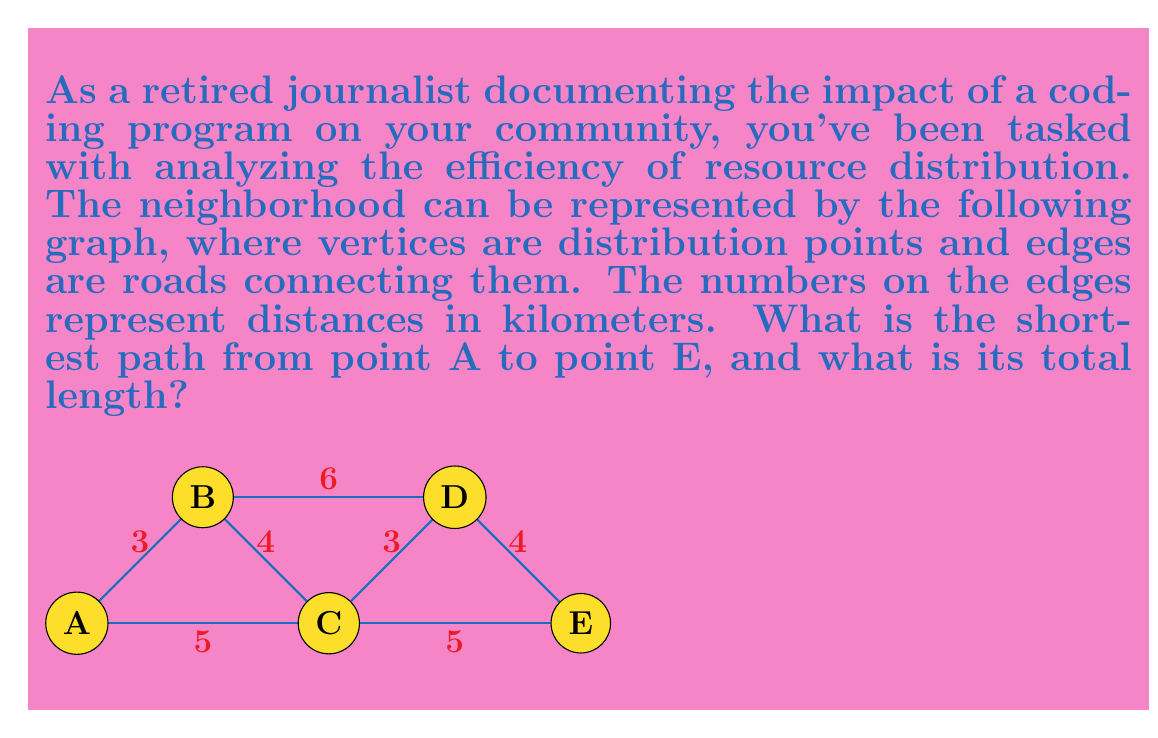Teach me how to tackle this problem. To solve this problem, we'll use Dijkstra's algorithm, a common method in topology for finding the shortest path between nodes in a graph.

Step 1: Initialize distances
Set the distance to A as 0 and all other nodes as infinity.
$d(A) = 0$, $d(B) = d(C) = d(D) = d(E) = \infty$

Step 2: Visit node A
Update distances to neighbors:
$d(B) = \min(\infty, 0 + 3) = 3$
$d(C) = \min(\infty, 0 + 5) = 5$

Step 3: Visit node B (closest unvisited node)
Update distances:
$d(C) = \min(5, 3 + 4) = 5$ (no change)
$d(D) = \min(\infty, 3 + 6) = 9$

Step 4: Visit node C
Update distances:
$d(D) = \min(9, 5 + 3) = 8$
$d(E) = \min(\infty, 5 + 5) = 10$

Step 5: Visit node D
Update distances:
$d(E) = \min(10, 8 + 4) = 10$ (no change)

Step 6: Visit node E
All nodes visited, algorithm terminates.

The shortest path from A to E is A -> C -> E, with a total length of 10 km.
Answer: A -> C -> E, 10 km 